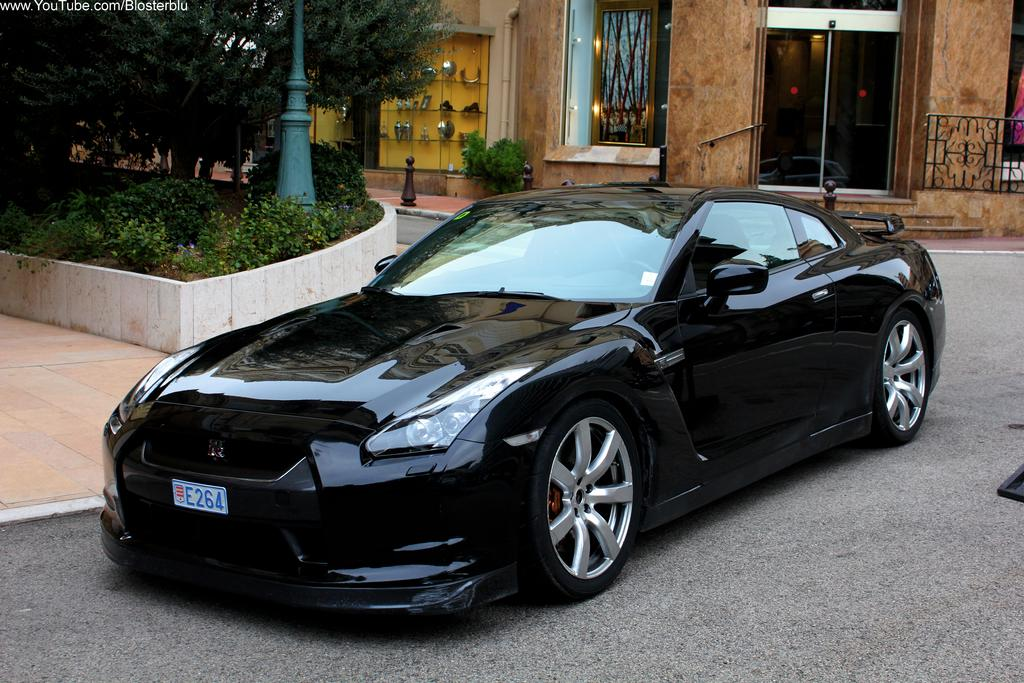What color is the car in the image? The car in the image is black. Where is the car located in the image? The car is on the road in the image. What can be seen in the background of the image? In the background of the image, there is a pole, plants, trees, a building, a fence, and other objects. How much profit does the car produce in the image? The car does not produce profit in the image, as it is an inanimate object and not a business entity. 